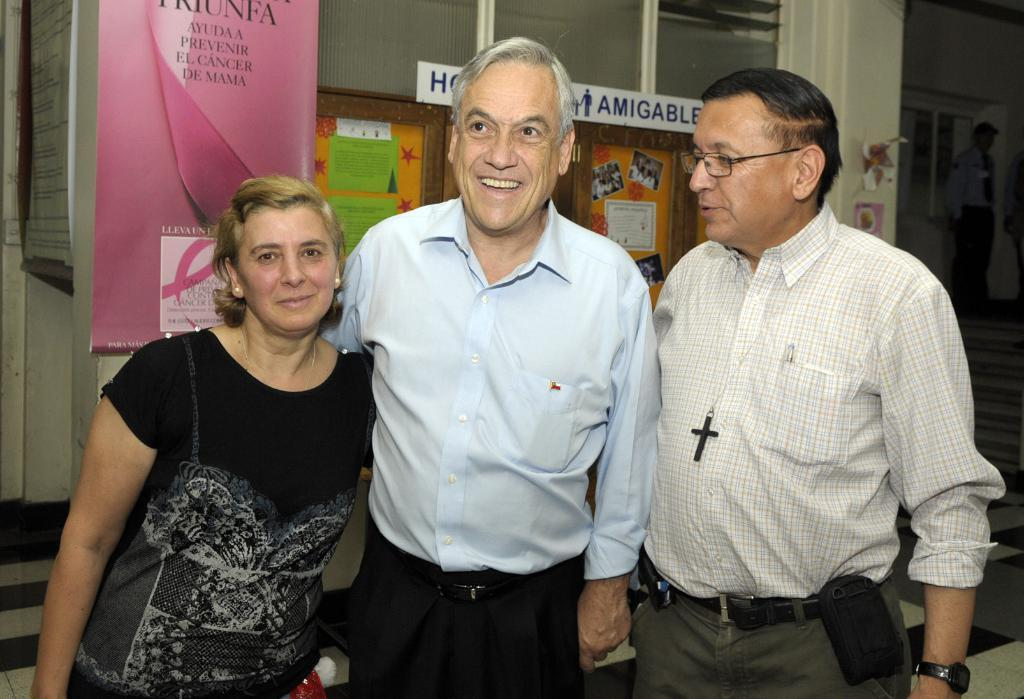How many people are in the image? There are three people in the image: two old men and a woman. Where are the people located in the image? The people are standing in the front of the image. What are the people doing in the image? The people are smiling and giving a pose to the camera. What can be seen in the background of the image? There is a pink banner and a notice board in the image. What type of linen is being used to sew the needle in the image? There is no linen or needle present in the image. How does the nerve of the old man affect his pose in the image? There is no mention of any nerve-related issues affecting the people's poses in the image. 